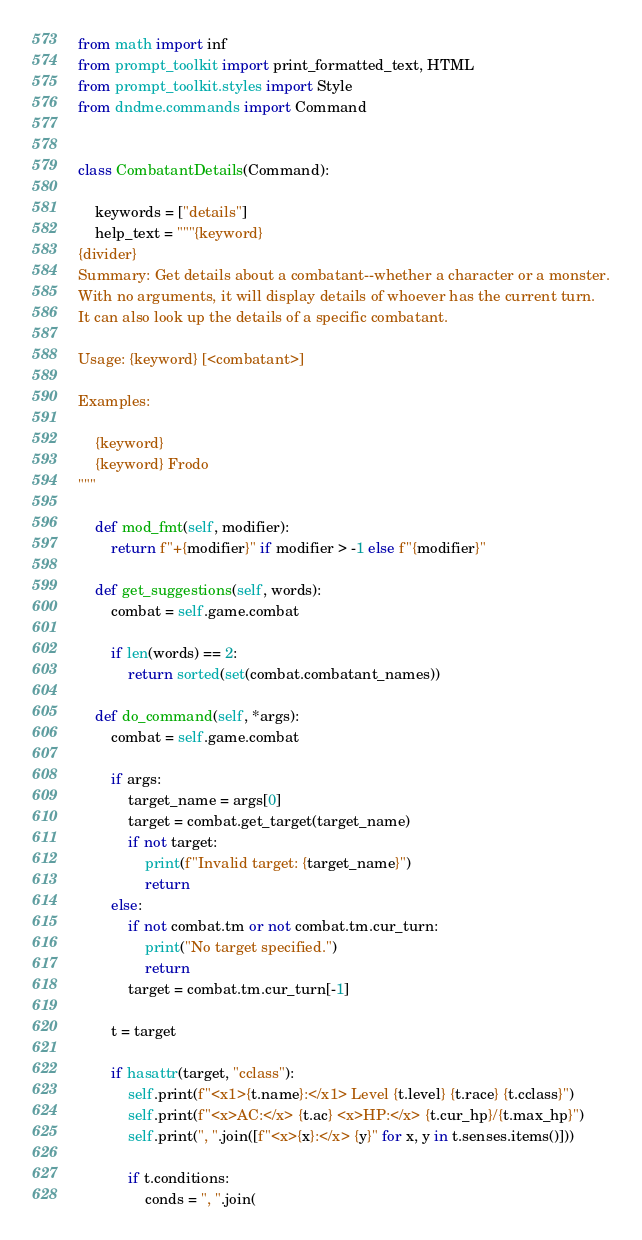<code> <loc_0><loc_0><loc_500><loc_500><_Python_>from math import inf
from prompt_toolkit import print_formatted_text, HTML
from prompt_toolkit.styles import Style
from dndme.commands import Command


class CombatantDetails(Command):

    keywords = ["details"]
    help_text = """{keyword}
{divider}
Summary: Get details about a combatant--whether a character or a monster.
With no arguments, it will display details of whoever has the current turn.
It can also look up the details of a specific combatant.

Usage: {keyword} [<combatant>]

Examples:

    {keyword}
    {keyword} Frodo
"""

    def mod_fmt(self, modifier):
        return f"+{modifier}" if modifier > -1 else f"{modifier}"

    def get_suggestions(self, words):
        combat = self.game.combat

        if len(words) == 2:
            return sorted(set(combat.combatant_names))

    def do_command(self, *args):
        combat = self.game.combat

        if args:
            target_name = args[0]
            target = combat.get_target(target_name)
            if not target:
                print(f"Invalid target: {target_name}")
                return
        else:
            if not combat.tm or not combat.tm.cur_turn:
                print("No target specified.")
                return
            target = combat.tm.cur_turn[-1]

        t = target

        if hasattr(target, "cclass"):
            self.print(f"<x1>{t.name}:</x1> Level {t.level} {t.race} {t.cclass}")
            self.print(f"<x>AC:</x> {t.ac} <x>HP:</x> {t.cur_hp}/{t.max_hp}")
            self.print(", ".join([f"<x>{x}:</x> {y}" for x, y in t.senses.items()]))

            if t.conditions:
                conds = ", ".join(</code> 